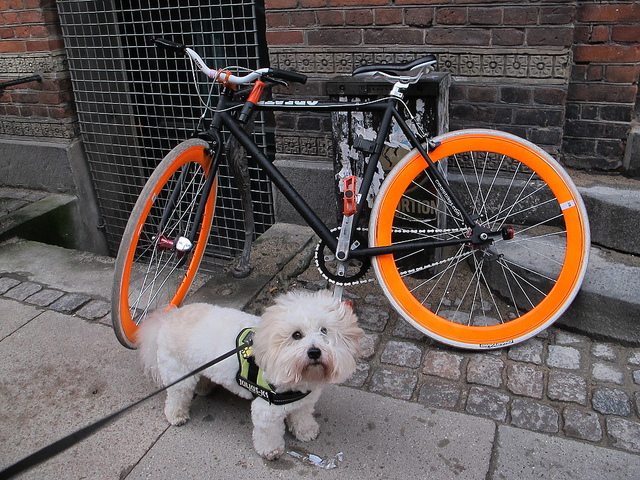Identify and read out the text in this image. RTION 